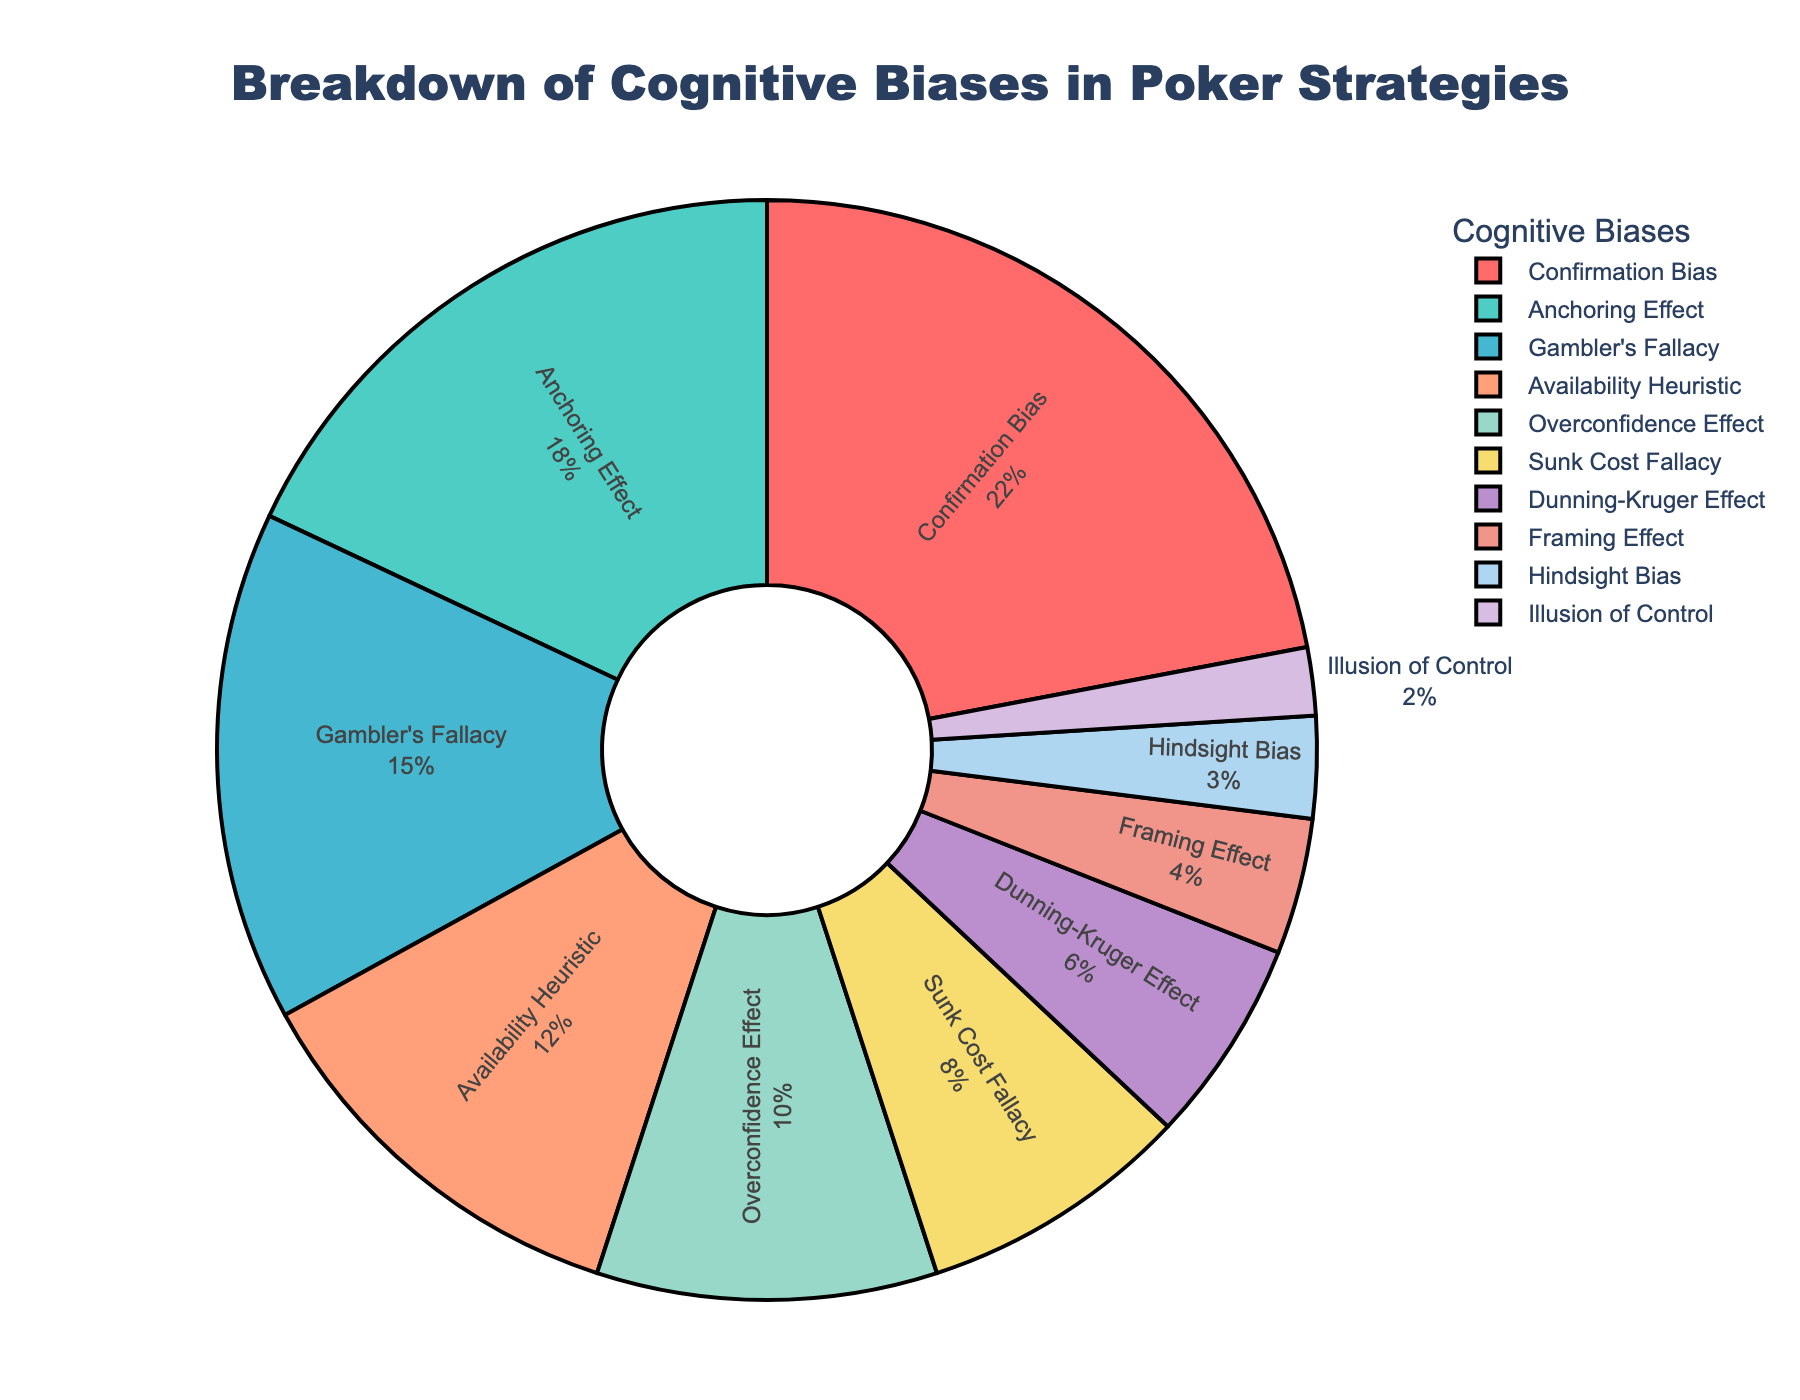Which cognitive bias is the most exploited in poker strategies? The pie chart shows each cognitive bias and its percentage. The largest slice represents the most exploited bias. Confirmation Bias has the largest percentage at 22%.
Answer: Confirmation Bias What is the combined percentage of Overconfidence Effect and Sunk Cost Fallacy? To find the combined percentage, add the percentages of Overconfidence Effect (10%) and Sunk Cost Fallacy (8%). 10% + 8% = 18%.
Answer: 18% Which cognitive bias has the smallest representation in the chart? The smallest slice in the pie chart represents the cognitive bias with the smallest percentage. Illusion of Control has the smallest slice at 2%.
Answer: Illusion of Control How does the percentage of Gambler's Fallacy compare to that of the Anchoring Effect? The pie chart shows the percentage of each cognitive bias. Compare the percentages of Gambler's Fallacy (15%) and Anchoring Effect (18%). Gambler's Fallacy (15%) is 3% less than Anchoring Effect (18%).
Answer: Anchoring Effect is 3% greater Are there more biases with a percentage greater than 10% or less than 10%? Count the biases with percentages greater than 10% and those less than 10%. Greater than 10% (Confirmation Bias, Anchoring Effect, Gambler's Fallacy, Availability Heuristic, Overconfidence Effect) are 5, and less than 10% (Sunk Cost Fallacy, Dunning-Kruger Effect, Framing Effect, Hindsight Bias, Illusion of Control) are 5.
Answer: Equal Which color represents the Framing Effect in the figure? The pie chart has specific colors for each cognitive bias. The label and corresponding slice for Framing Effect is matched with a light pinkish color.
Answer: Light pink Sum up the percentages for the biases named Framing Effect and Dunning-Kruger Effect. Add the percentages of Framing Effect (4%) and Dunning-Kruger Effect (6%). 4% + 6% = 10%.
Answer: 10% Is the Availability Heuristic more exploited than Overconfidence Effect? Compare the percentages of Availability Heuristic (12%) and Overconfidence Effect (10%). Availability Heuristic (12%) is more exploited than Overconfidence Effect (10%).
Answer: Yes How do the percentages of biases represented by red and blue colors compare? Identify which biases are represented by red (e.g., Framing Effect) and blue (e.g., Gambler's Fallacy), then compare their percentages. Framing Effect (4%) in red is less than Gambler's Fallacy (15%) in blue.
Answer: Blue represents a higher percentage 